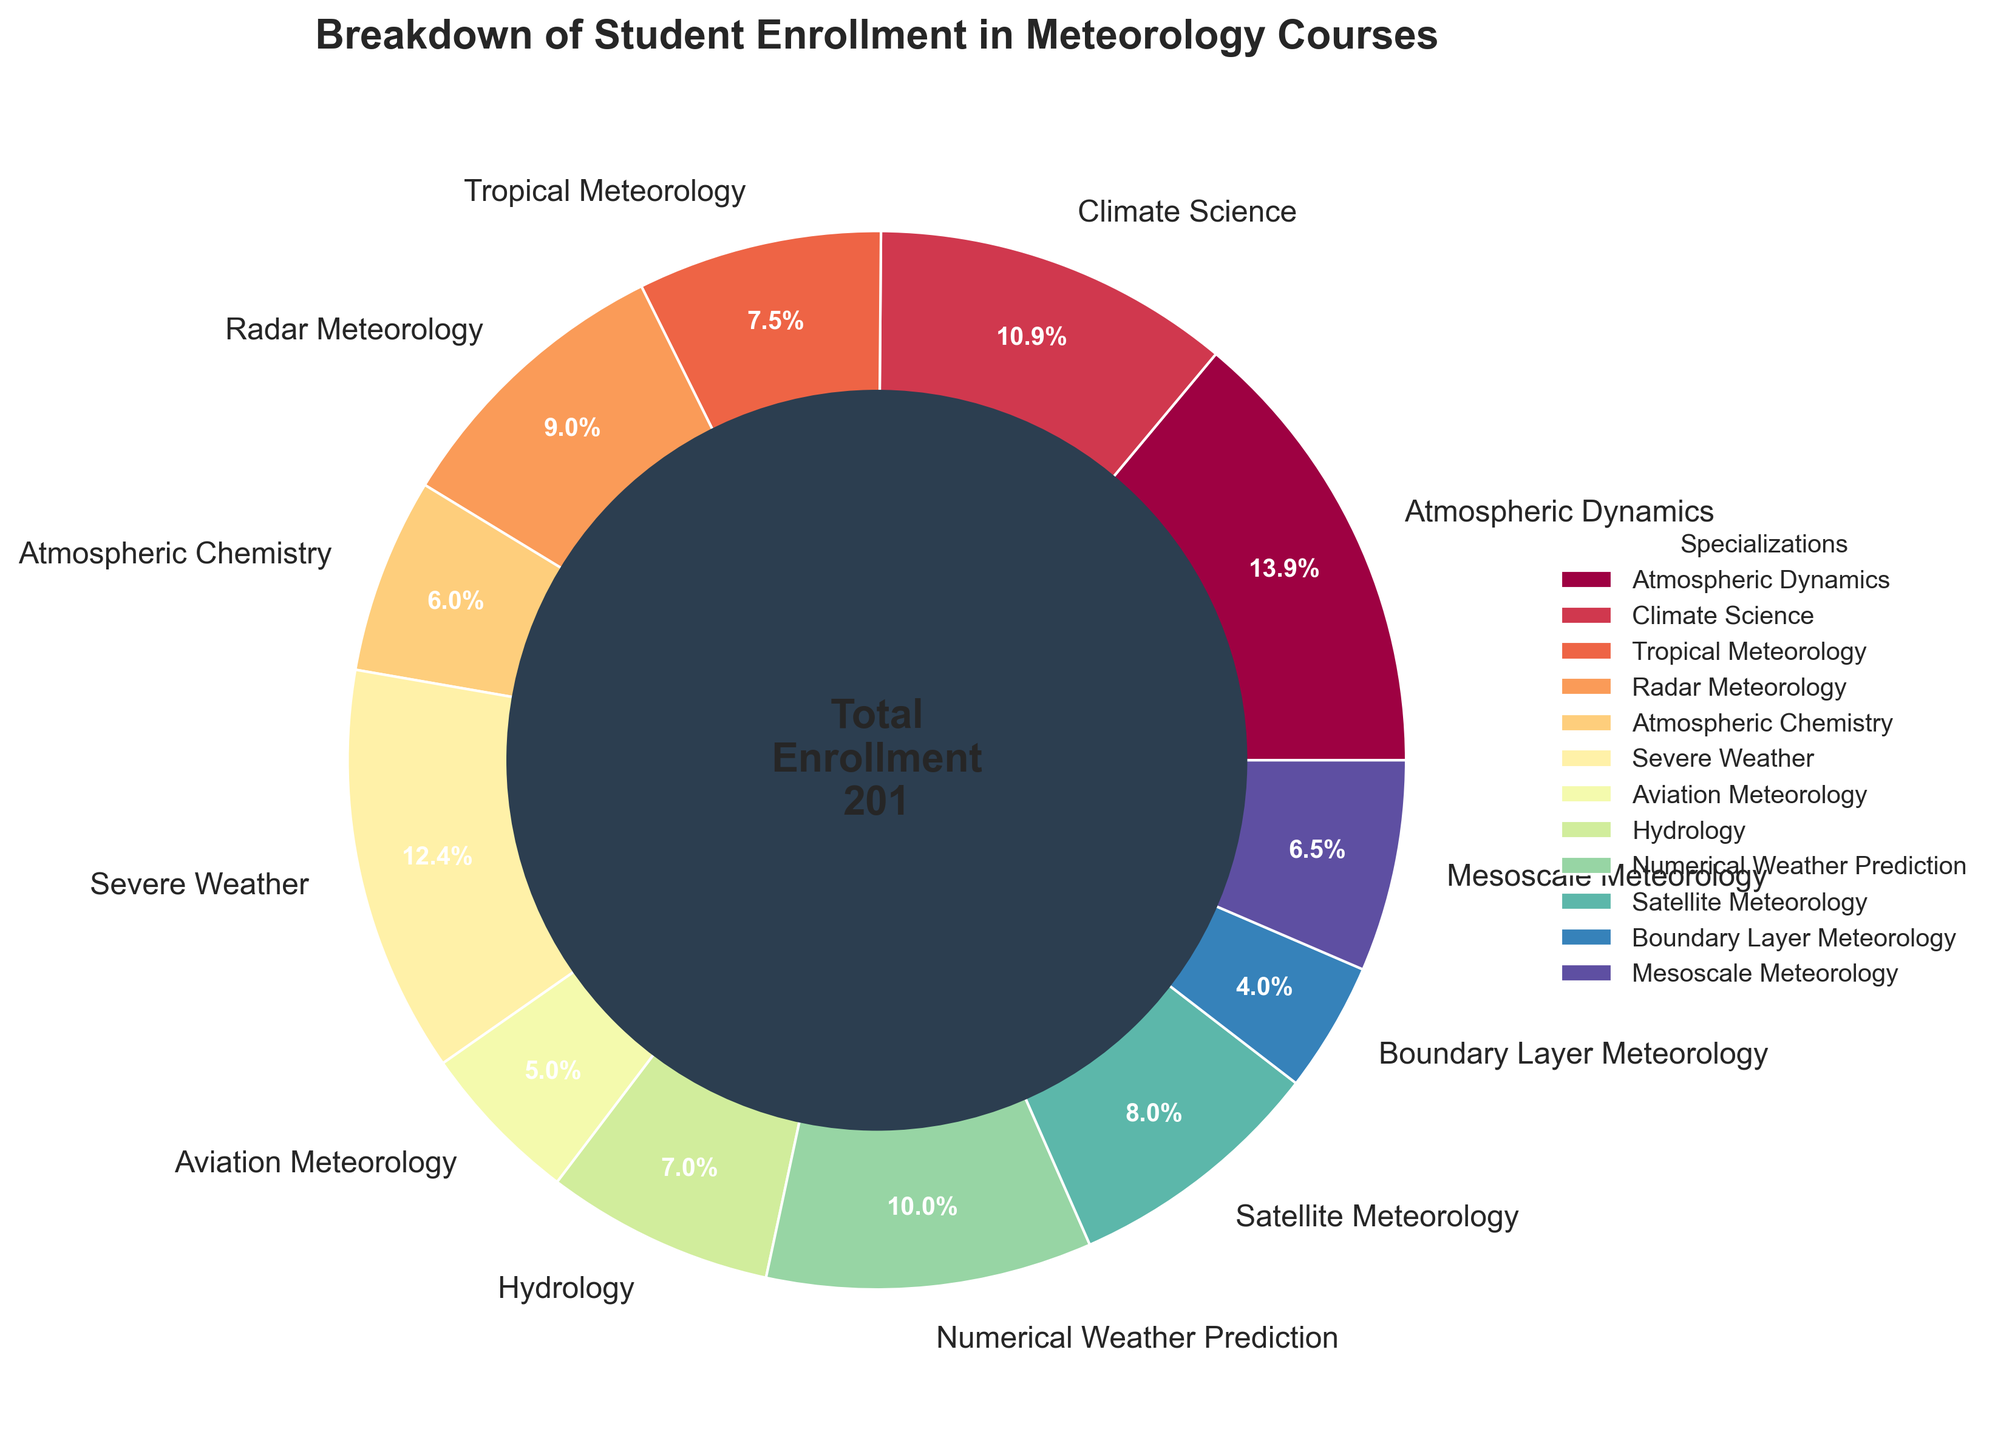Which specialization has the highest student enrollment? By observing the pie chart, it's clear that Atmospheric Dynamics has the largest portion of the pie, indicating the highest enrollment.
Answer: Atmospheric Dynamics Which specialization has the lowest student enrollment? The smallest slice of the pie chart belongs to Boundary Layer Meteorology, indicating the lowest enrollment.
Answer: Boundary Layer Meteorology What is the total enrollment for Climate Science and Radar Meteorology combined? Looking at the pie chart, identify the enrollment numbers: Climate Science (22) and Radar Meteorology (18). Summing these gives 22 + 18 = 40.
Answer: 40 Is the enrollment for Severe Weather higher or lower than Aviation Meteorology? From the pie chart, compare the sections: Severe Weather (25) has higher enrollment than Aviation Meteorology (10).
Answer: Higher How much larger is the enrollment in Tropical Meteorology compared to Mesoscale Meteorology? From the pie chart, Tropical Meteorology has 15 students and Mesoscale Meteorology has 13 students. The difference is 15 - 13 = 2.
Answer: 2 What percentage of total enrollment does Hydrology represent? From the pie chart, Hydrology enrollment is 14. Sum all enrollments to get total (28+22+15+18+12+25+10+14+20+16+8+13 = 201). The percentage is (14/201) * 100 ≈ 6.97%.
Answer: 6.97% How does the enrollment in Numerical Weather Prediction compare to Satellite Meteorology? From the pie chart, Numerical Weather Prediction has 20 students, and Satellite Meteorology has 16 students. Numerical Weather Prediction has more students.
Answer: Numerical Weather Prediction has more Which specialization has more students, Atmospheric Chemistry or Boundary Layer Meteorology? From the pie chart, Atmospheric Chemistry has 12 students, and Boundary Layer Meteorology has 8. Atmospheric Chemistry has more students.
Answer: Atmospheric Chemistry What is the average enrollment across all specializations? Sum all enrollments (28+22+15+18+12+25+10+14+20+16+8+13 = 201) and divide by the number of specializations (12). The average is 201 / 12 ≈ 16.75.
Answer: 16.75 